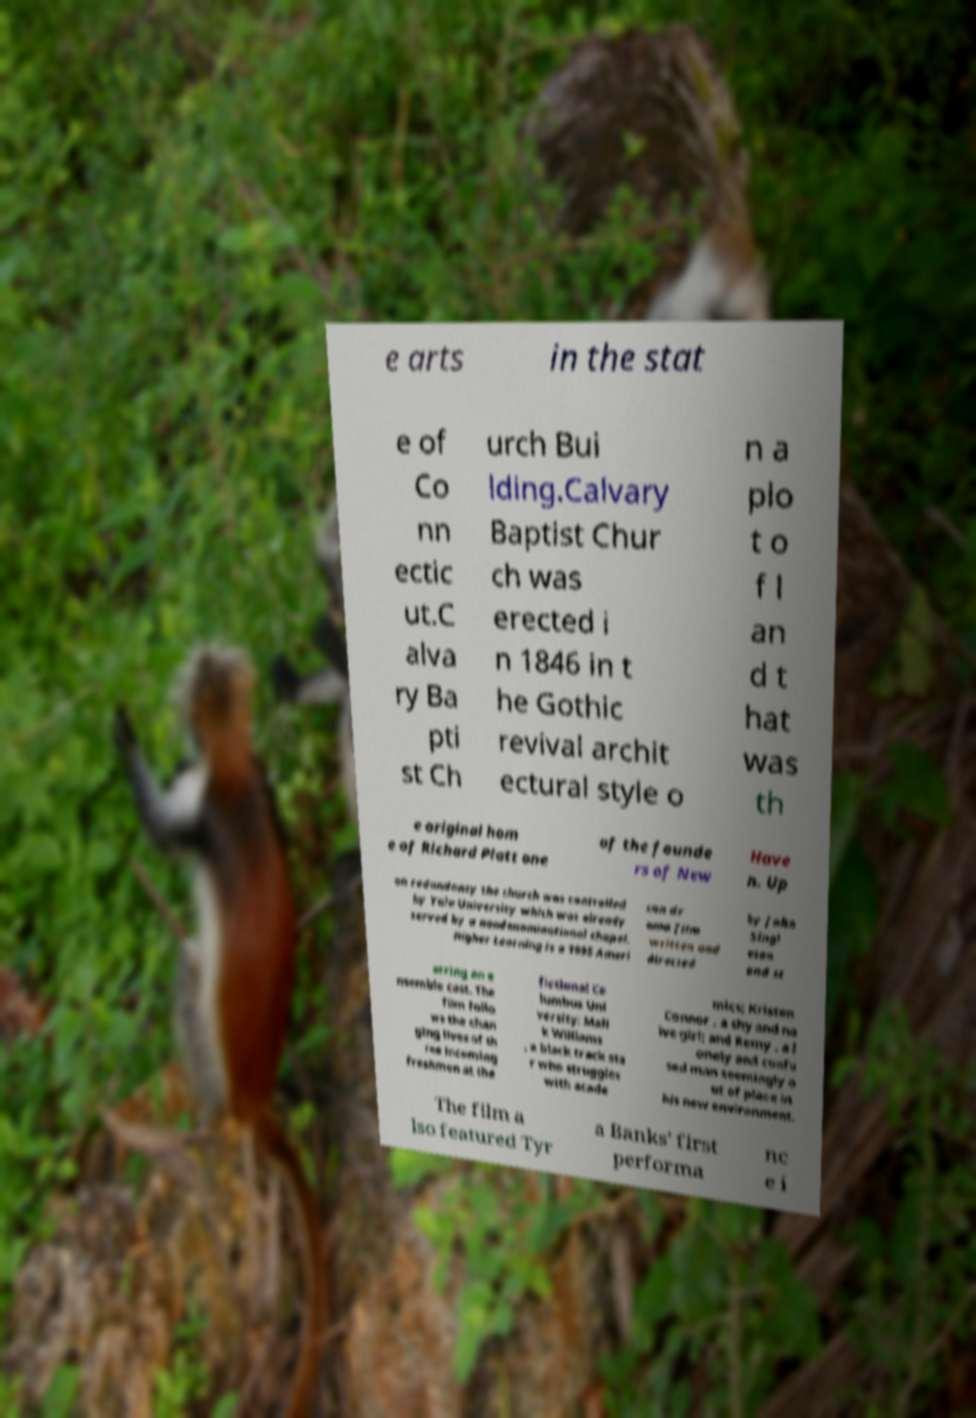Could you extract and type out the text from this image? e arts in the stat e of Co nn ectic ut.C alva ry Ba pti st Ch urch Bui lding.Calvary Baptist Chur ch was erected i n 1846 in t he Gothic revival archit ectural style o n a plo t o f l an d t hat was th e original hom e of Richard Platt one of the founde rs of New Have n. Up on redundancy the church was controlled by Yale University which was already served by a nondenominational chapel. Higher Learning is a 1995 Ameri can dr ama film written and directed by John Singl eton and st arring an e nsemble cast. The film follo ws the chan ging lives of th ree incoming freshmen at the fictional Co lumbus Uni versity: Mali k Williams , a black track sta r who struggles with acade mics; Kristen Connor , a shy and na ive girl; and Remy , a l onely and confu sed man seemingly o ut of place in his new environment. The film a lso featured Tyr a Banks' first performa nc e i 